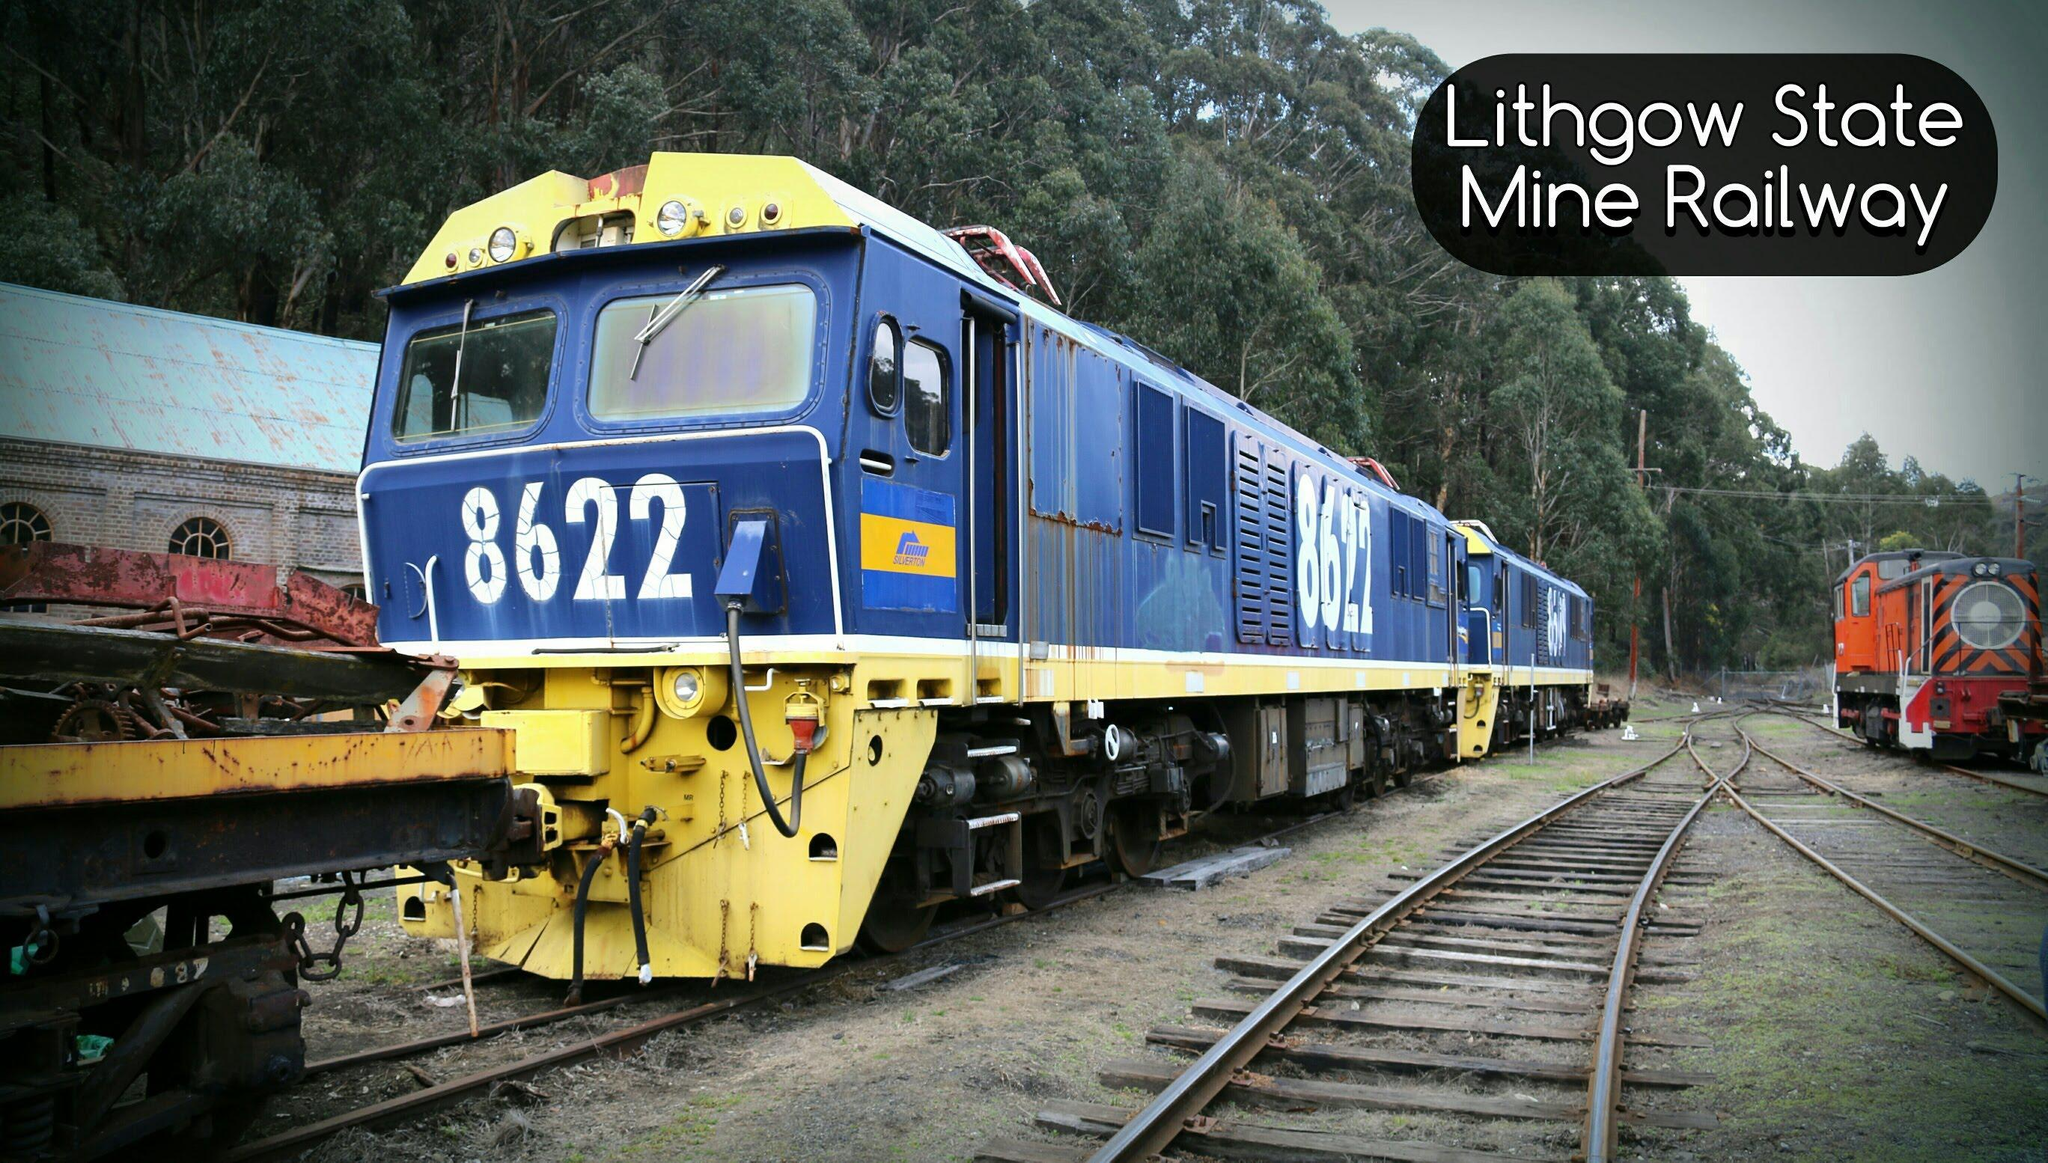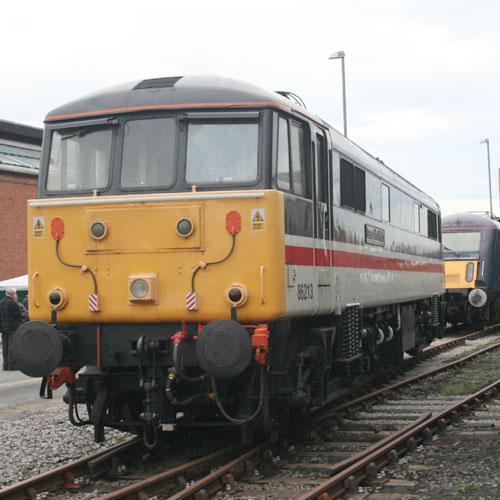The first image is the image on the left, the second image is the image on the right. Analyze the images presented: Is the assertion "An image shows a train with a yellow front and a red side stripe, angled heading leftward." valid? Answer yes or no. Yes. 